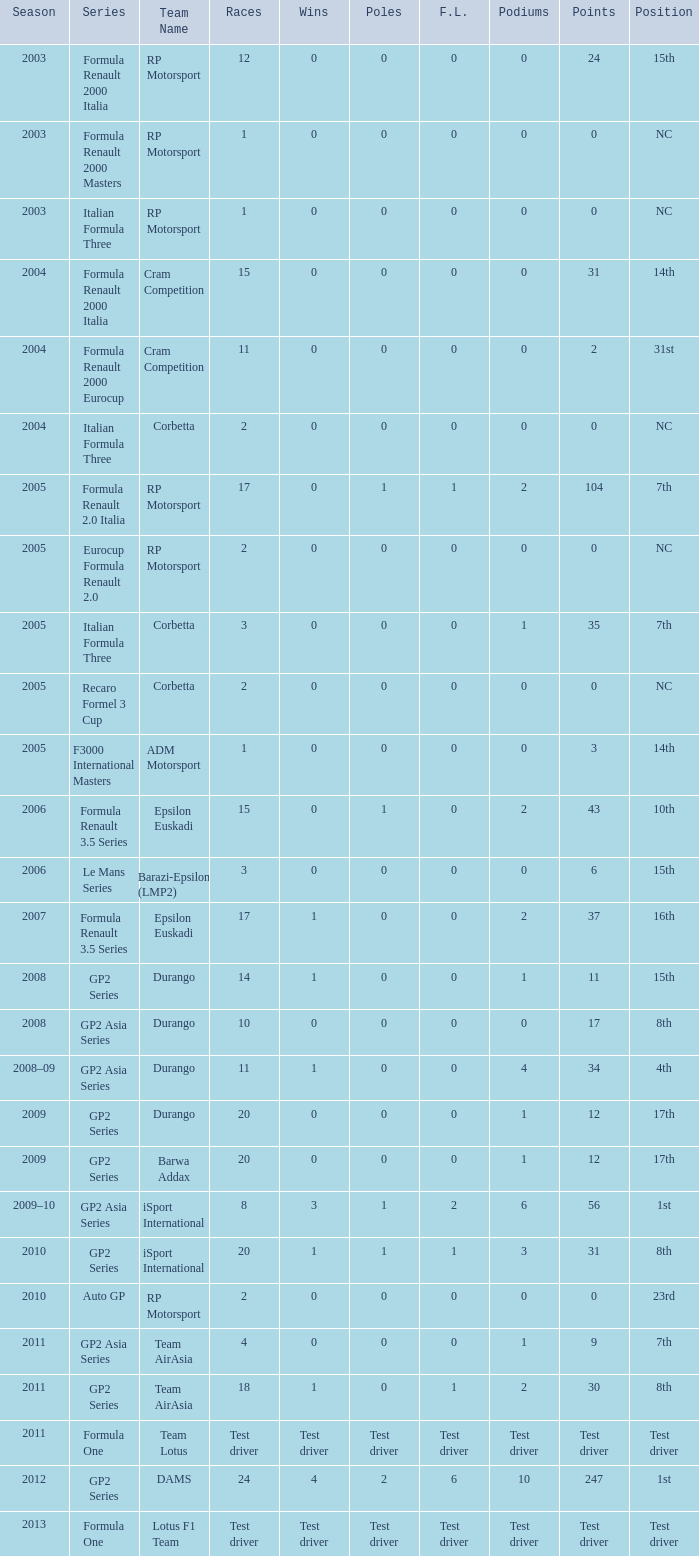What contests include gp2 series, 0 f.l. and a 17th spot? 20, 20. 